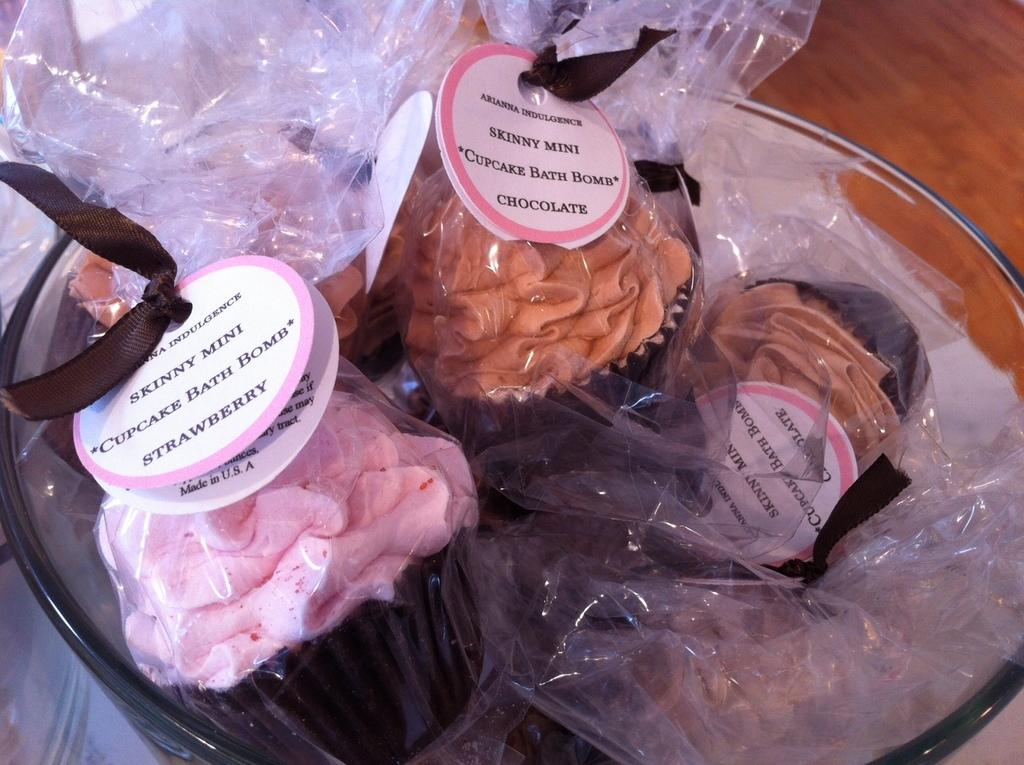What is inside the plastic bags in the image? There is food in the plastic bags in the image. What else can be seen in the image besides the plastic bags? There is a bowl in the image. What type of feeling does the creator of the image want to convey through the use of plastic bags? The image does not convey any specific feelings, and there is no information about a creator. The focus is on the objects present in the image, which are the plastic bags containing food and the bowl. 